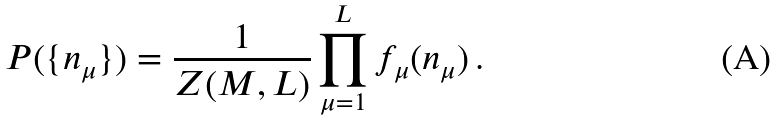Convert formula to latex. <formula><loc_0><loc_0><loc_500><loc_500>P ( \{ n _ { \mu } \} ) = \frac { 1 } { Z ( M , L ) } \prod _ { \mu = 1 } ^ { L } f _ { \mu } ( n _ { \mu } ) \, .</formula> 